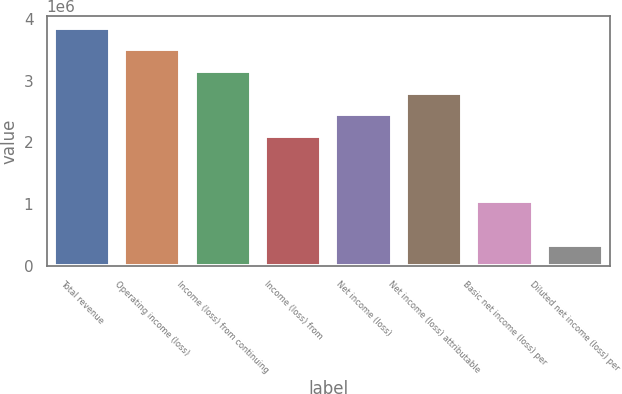Convert chart. <chart><loc_0><loc_0><loc_500><loc_500><bar_chart><fcel>Total revenue<fcel>Operating income (loss)<fcel>Income (loss) from continuing<fcel>Income (loss) from<fcel>Net income (loss)<fcel>Net income (loss) attributable<fcel>Basic net income (loss) per<fcel>Diluted net income (loss) per<nl><fcel>3.85552e+06<fcel>3.50502e+06<fcel>3.15452e+06<fcel>2.10301e+06<fcel>2.45351e+06<fcel>2.80402e+06<fcel>1.05151e+06<fcel>350502<nl></chart> 